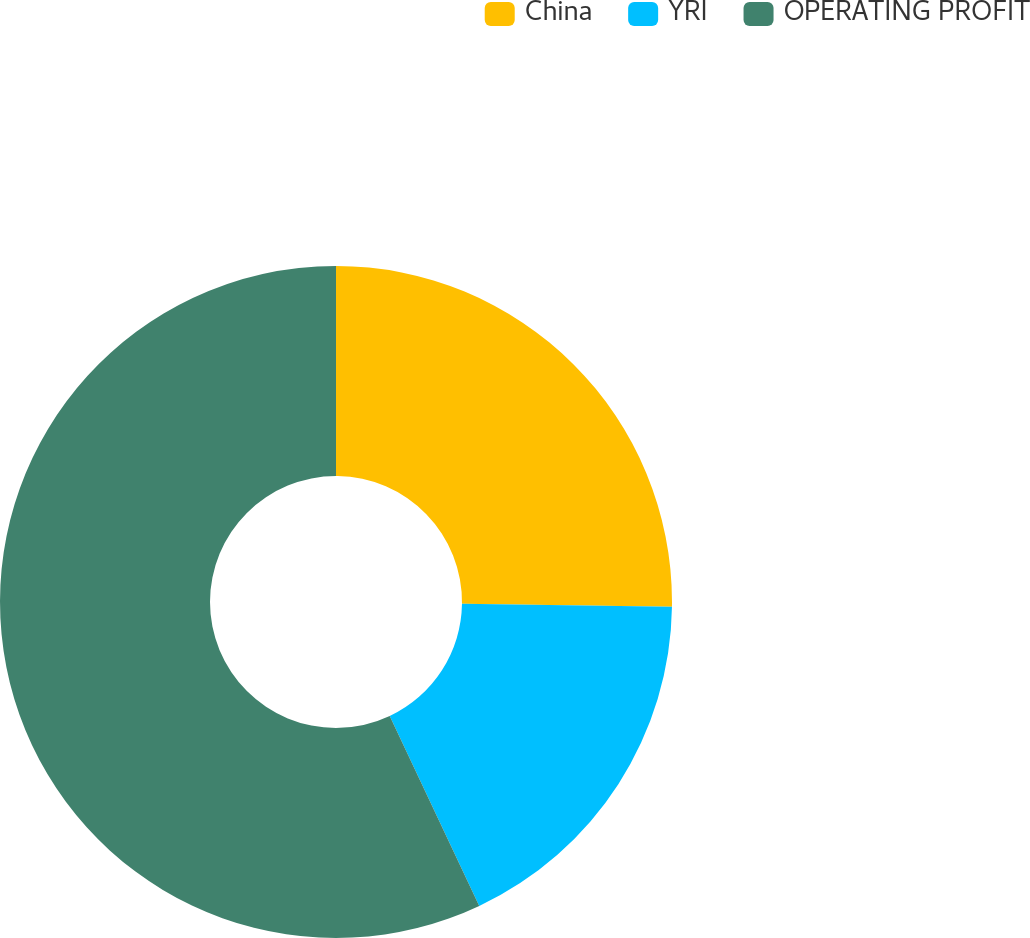<chart> <loc_0><loc_0><loc_500><loc_500><pie_chart><fcel>China<fcel>YRI<fcel>OPERATING PROFIT<nl><fcel>25.22%<fcel>17.77%<fcel>57.01%<nl></chart> 